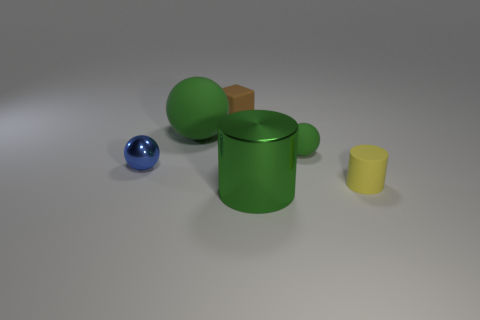The ball that is in front of the green object on the right side of the shiny object right of the block is made of what material? metal 